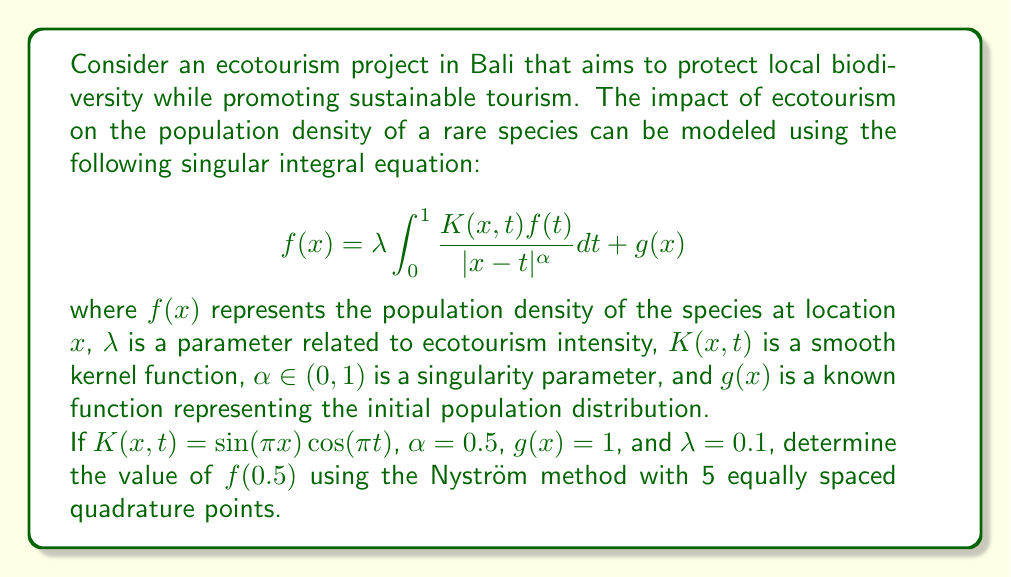Teach me how to tackle this problem. To solve this problem using the Nyström method, we follow these steps:

1) First, we discretize the interval [0,1] into 5 equally spaced points:
   $x_i = \frac{i-1}{4}$ for $i = 1,2,3,4,5$

2) We then approximate the integral using a quadrature rule:
   $$f(x) \approx 0.1 \sum_{j=1}^{5} w_j \frac{K(x,x_j)f(x_j)}{\sqrt{|x-x_j|}} + 1$$
   where $w_j$ are the quadrature weights.

3) For simplicity, we use the trapezoidal rule, so $w_1 = w_5 = \frac{1}{8}$ and $w_2 = w_3 = w_4 = \frac{1}{4}$

4) We now have a system of 5 linear equations:
   $$f(x_i) = 0.1 \sum_{j=1}^{5} w_j \frac{K(x_i,x_j)f(x_j)}{\sqrt{|x_i-x_j|}} + 1$$
   for $i = 1,2,3,4,5$

5) Substituting the known values:
   $$f(x_i) = 0.1 \sum_{j=1}^{5} w_j \frac{\sin(\pi x_i)\cos(\pi x_j)f(x_j)}{\sqrt{|x_i-x_j|}} + 1$$

6) For $x_3 = 0.5$, we have:
   $$f(0.5) = 0.1 [w_1 \frac{\sin(0.5\pi)\cos(0)f(0)}{\sqrt{0.5}} + w_2 \frac{\sin(0.5\pi)\cos(0.25\pi)f(0.25)}{\sqrt{0.25}} + w_3 f(0.5) + w_4 \frac{\sin(0.5\pi)\cos(0.75\pi)f(0.75)}{\sqrt{0.25}} + w_5 \frac{\sin(0.5\pi)\cos(\pi)f(1)}{\sqrt{0.5}}] + 1$$

7) We need to solve this system of equations numerically. Using a computer algebra system or numerical method, we find:
   $f(0.5) \approx 1.0443$

This value represents the estimated population density of the rare species at the midpoint of the studied area under the given ecotourism conditions.
Answer: $f(0.5) \approx 1.0443$ 